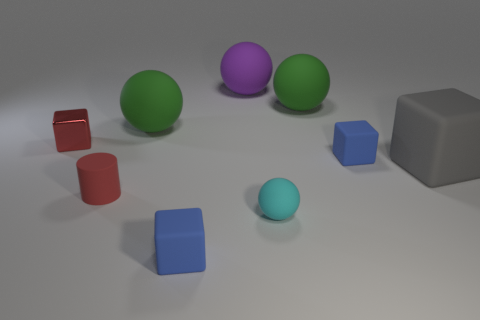Add 1 rubber things. How many objects exist? 10 Subtract all balls. How many objects are left? 5 Subtract all yellow matte balls. Subtract all small red rubber objects. How many objects are left? 8 Add 6 tiny red cylinders. How many tiny red cylinders are left? 7 Add 6 gray matte objects. How many gray matte objects exist? 7 Subtract 1 red cubes. How many objects are left? 8 